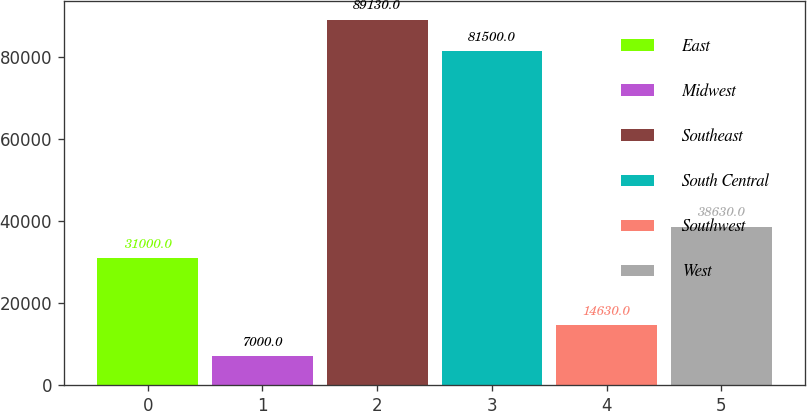<chart> <loc_0><loc_0><loc_500><loc_500><bar_chart><fcel>East<fcel>Midwest<fcel>Southeast<fcel>South Central<fcel>Southwest<fcel>West<nl><fcel>31000<fcel>7000<fcel>89130<fcel>81500<fcel>14630<fcel>38630<nl></chart> 